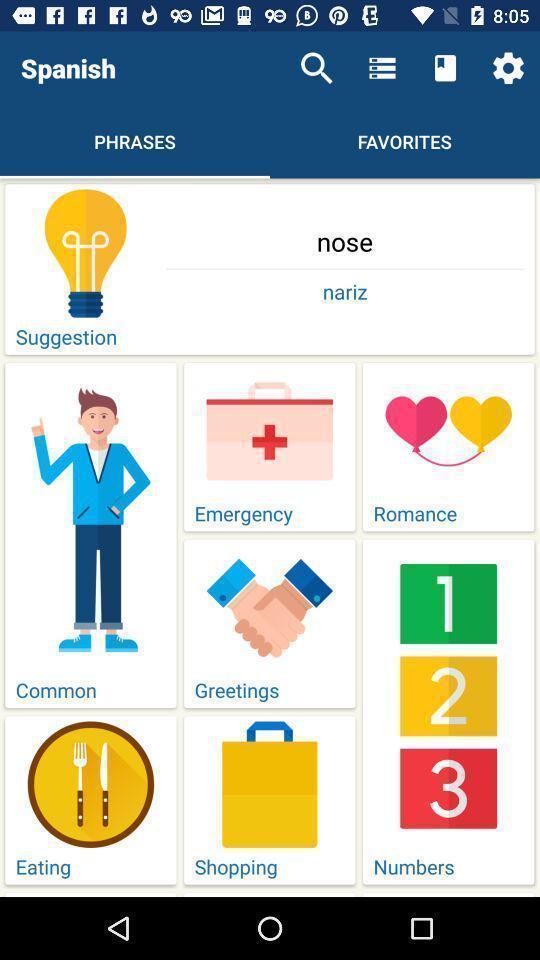Describe this image in words. Page showing phrases in an language learning application. 